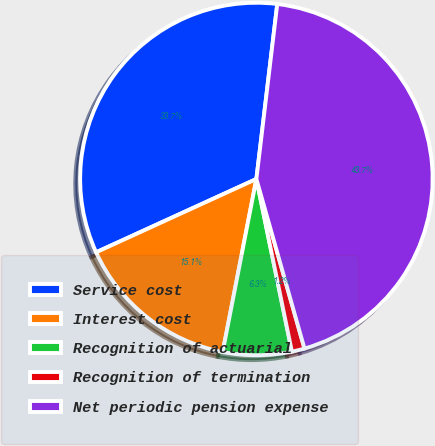Convert chart to OTSL. <chart><loc_0><loc_0><loc_500><loc_500><pie_chart><fcel>Service cost<fcel>Interest cost<fcel>Recognition of actuarial<fcel>Recognition of termination<fcel>Net periodic pension expense<nl><fcel>33.72%<fcel>15.11%<fcel>6.29%<fcel>1.17%<fcel>43.71%<nl></chart> 